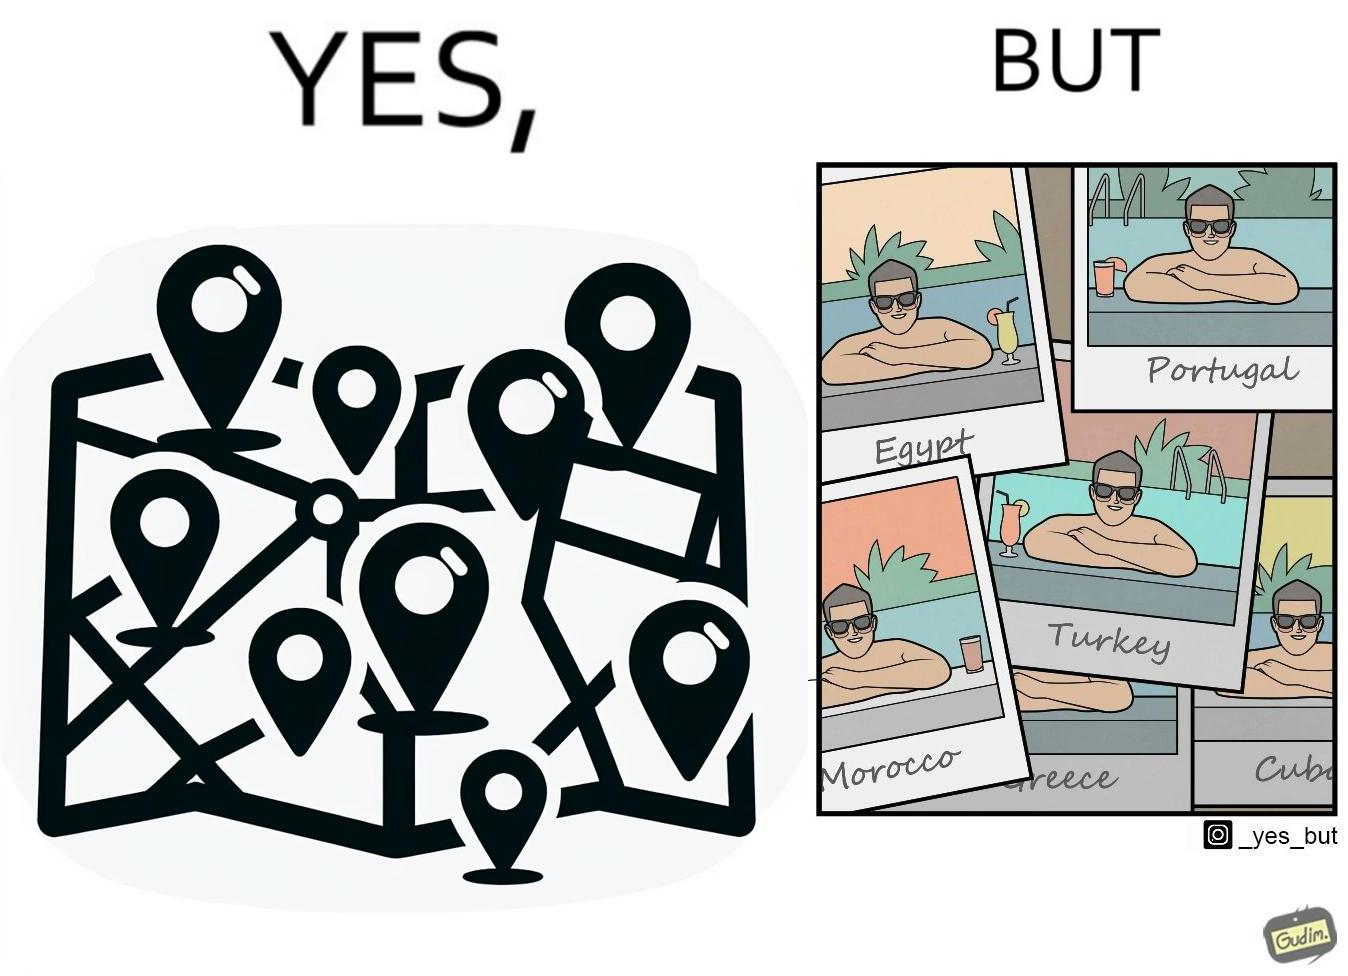Is there satirical content in this image? Yes, this image is satirical. 